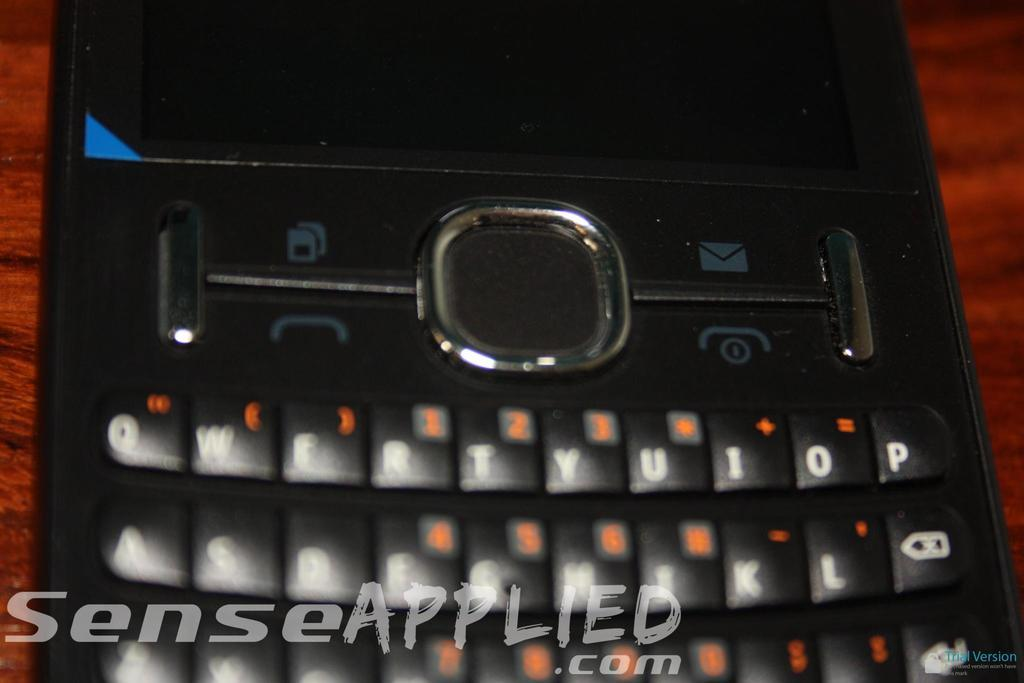<image>
Give a short and clear explanation of the subsequent image. SenseApplied.com in the foreground and a cell phone on a maroon table. 